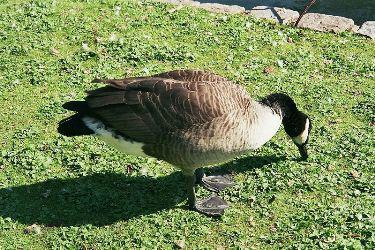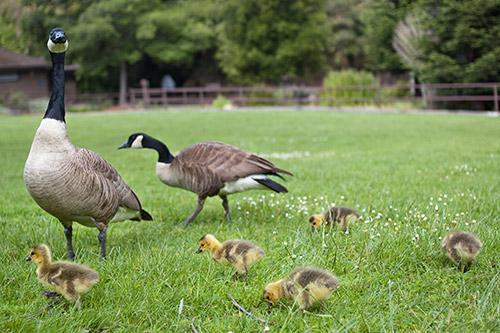The first image is the image on the left, the second image is the image on the right. Analyze the images presented: Is the assertion "There is an image of a single goose that has its head bent to the ground." valid? Answer yes or no. Yes. The first image is the image on the left, the second image is the image on the right. Analyze the images presented: Is the assertion "There are no more than four birds." valid? Answer yes or no. No. 